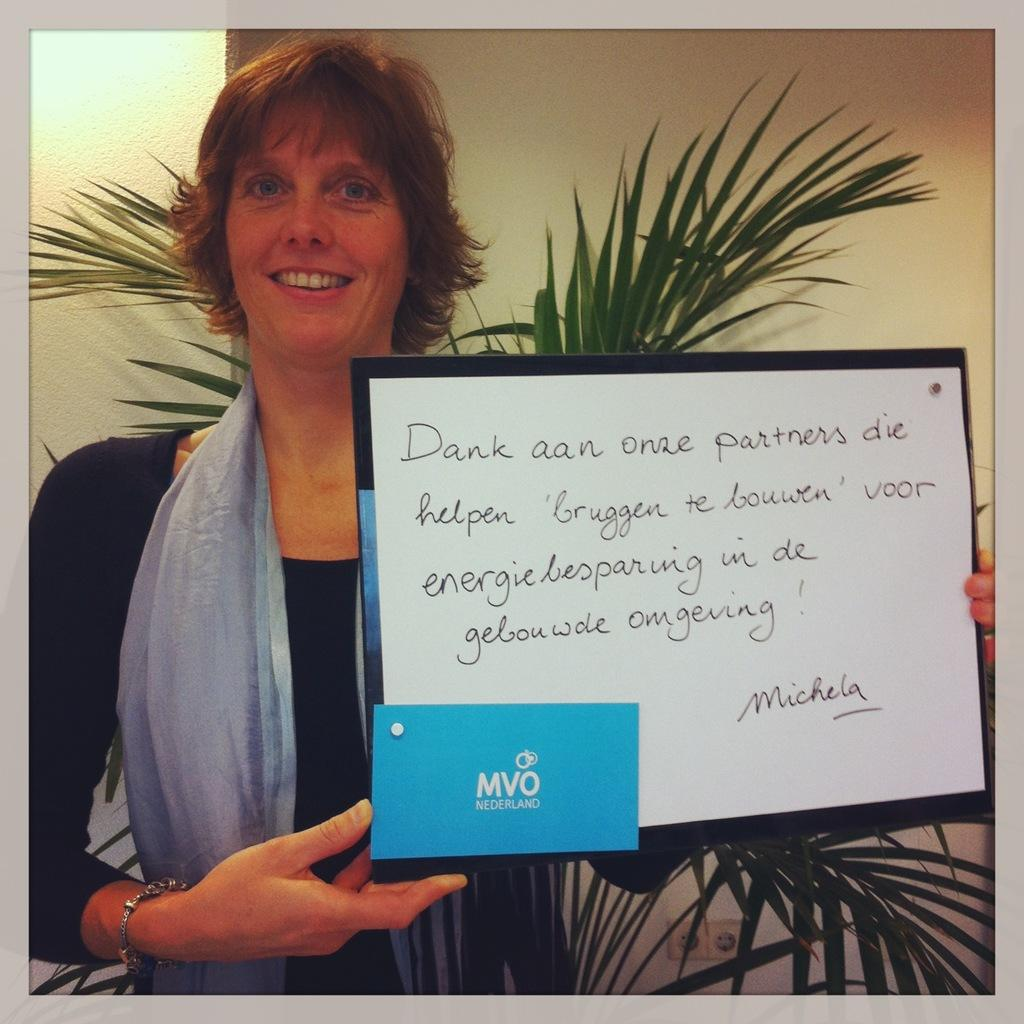What is the main subject of the image? The main subject of the image is a woman. What is the woman holding in the image? The woman is holding a board. What can be seen in the background of the image? There is a potted plant and a wall in the background of the image. How many letters are visible on the cast in the image? There is no cast present in the image, and therefore no letters can be observed on it. What word is being spelled out by the woman in the image? There is no indication in the image that the woman is spelling out a word. 